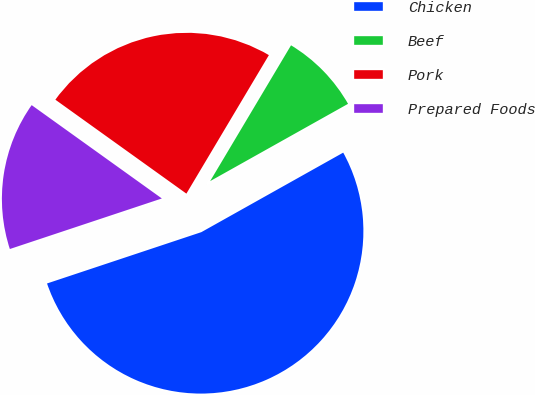Convert chart to OTSL. <chart><loc_0><loc_0><loc_500><loc_500><pie_chart><fcel>Chicken<fcel>Beef<fcel>Pork<fcel>Prepared Foods<nl><fcel>53.02%<fcel>8.32%<fcel>23.65%<fcel>15.01%<nl></chart> 